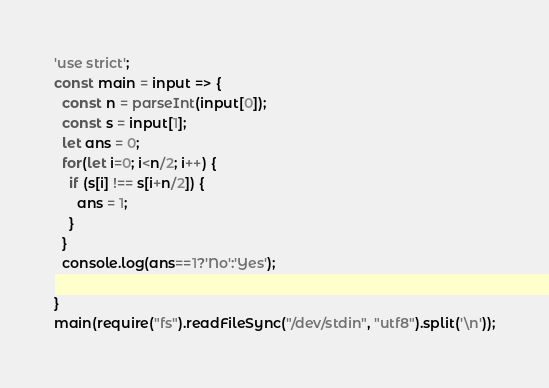Convert code to text. <code><loc_0><loc_0><loc_500><loc_500><_JavaScript_>'use strict';
const main = input => {
  const n = parseInt(input[0]);
  const s = input[1];
  let ans = 0;
  for(let i=0; i<n/2; i++) {
    if (s[i] !== s[i+n/2]) {
      ans = 1;
    }
  }
  console.log(ans==1?'No':'Yes');
  
}
main(require("fs").readFileSync("/dev/stdin", "utf8").split('\n'));</code> 